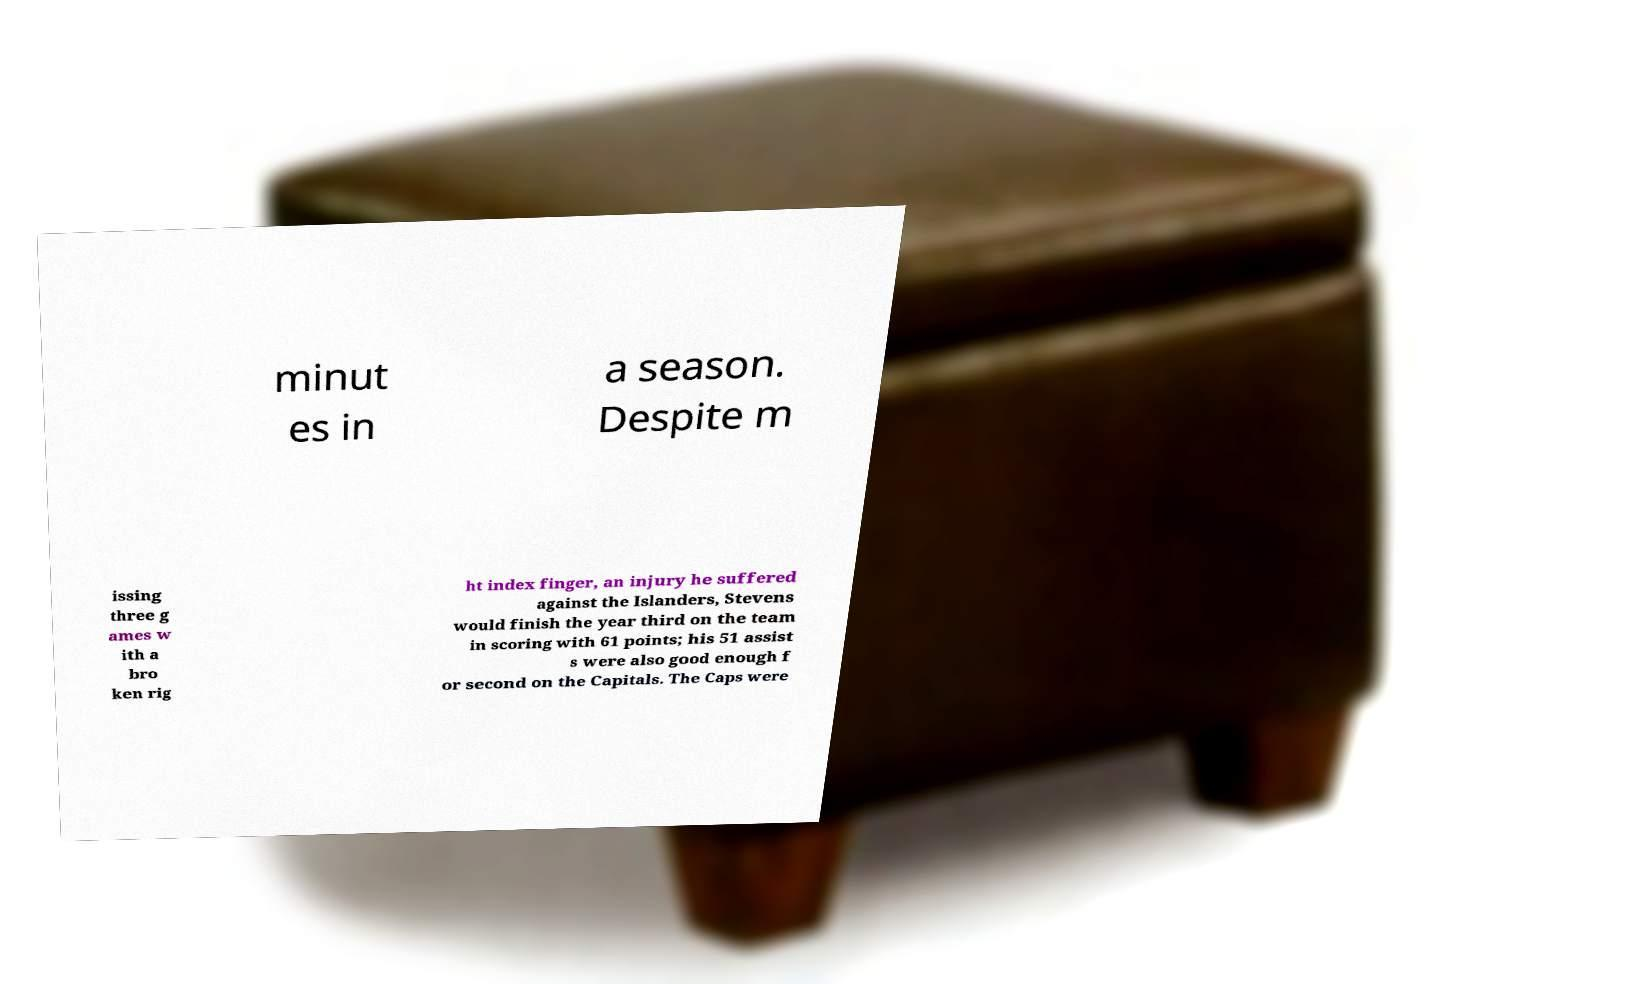Please identify and transcribe the text found in this image. minut es in a season. Despite m issing three g ames w ith a bro ken rig ht index finger, an injury he suffered against the Islanders, Stevens would finish the year third on the team in scoring with 61 points; his 51 assist s were also good enough f or second on the Capitals. The Caps were 